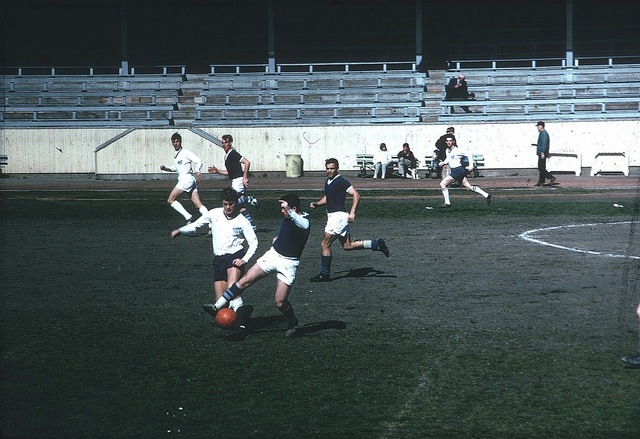Describe the objects in this image and their specific colors. I can see people in black, white, gray, and darkgray tones, people in black, white, gray, and darkgray tones, bench in black, gray, and darkgray tones, people in black, white, gray, and navy tones, and bench in black, gray, and lightblue tones in this image. 